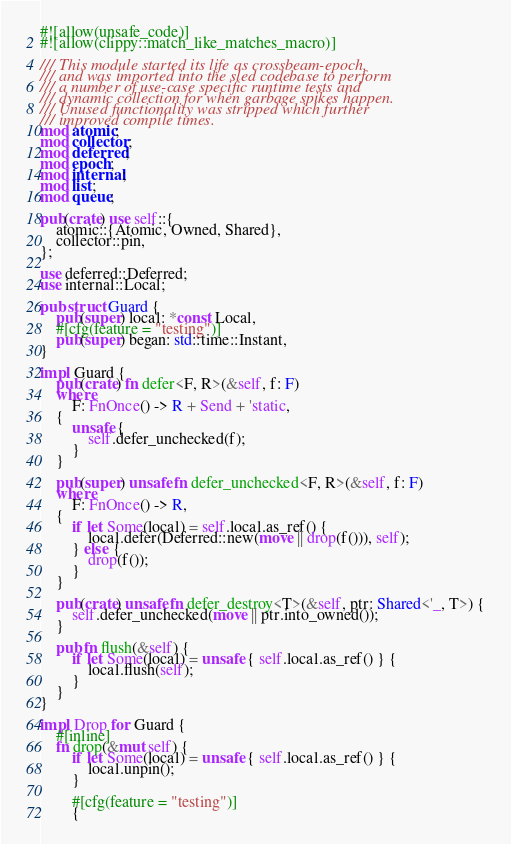Convert code to text. <code><loc_0><loc_0><loc_500><loc_500><_Rust_>#![allow(unsafe_code)]
#![allow(clippy::match_like_matches_macro)]

/// This module started its life as crossbeam-epoch,
/// and was imported into the sled codebase to perform
/// a number of use-case specific runtime tests and
/// dynamic collection for when garbage spikes happen.
/// Unused functionality was stripped which further
/// improved compile times.
mod atomic;
mod collector;
mod deferred;
mod epoch;
mod internal;
mod list;
mod queue;

pub(crate) use self::{
    atomic::{Atomic, Owned, Shared},
    collector::pin,
};

use deferred::Deferred;
use internal::Local;

pub struct Guard {
    pub(super) local: *const Local,
    #[cfg(feature = "testing")]
    pub(super) began: std::time::Instant,
}

impl Guard {
    pub(crate) fn defer<F, R>(&self, f: F)
    where
        F: FnOnce() -> R + Send + 'static,
    {
        unsafe {
            self.defer_unchecked(f);
        }
    }

    pub(super) unsafe fn defer_unchecked<F, R>(&self, f: F)
    where
        F: FnOnce() -> R,
    {
        if let Some(local) = self.local.as_ref() {
            local.defer(Deferred::new(move || drop(f())), self);
        } else {
            drop(f());
        }
    }

    pub(crate) unsafe fn defer_destroy<T>(&self, ptr: Shared<'_, T>) {
        self.defer_unchecked(move || ptr.into_owned());
    }

    pub fn flush(&self) {
        if let Some(local) = unsafe { self.local.as_ref() } {
            local.flush(self);
        }
    }
}

impl Drop for Guard {
    #[inline]
    fn drop(&mut self) {
        if let Some(local) = unsafe { self.local.as_ref() } {
            local.unpin();
        }

        #[cfg(feature = "testing")]
        {</code> 